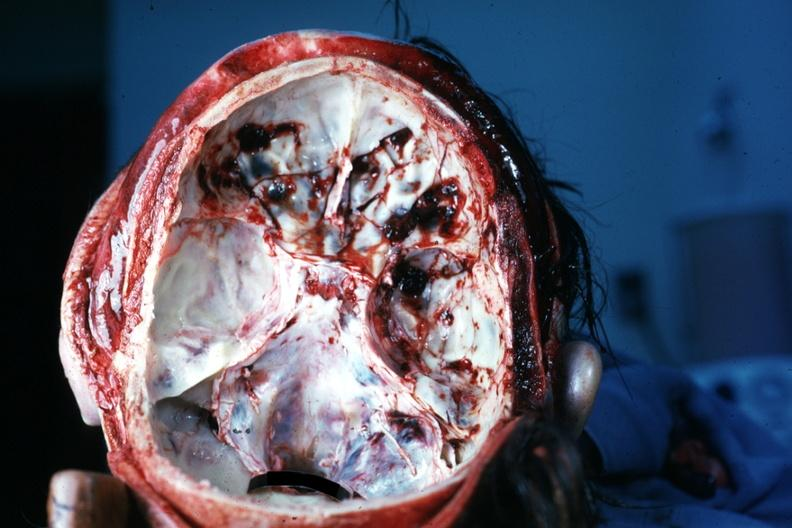what is present?
Answer the question using a single word or phrase. Basilar skull fracture 